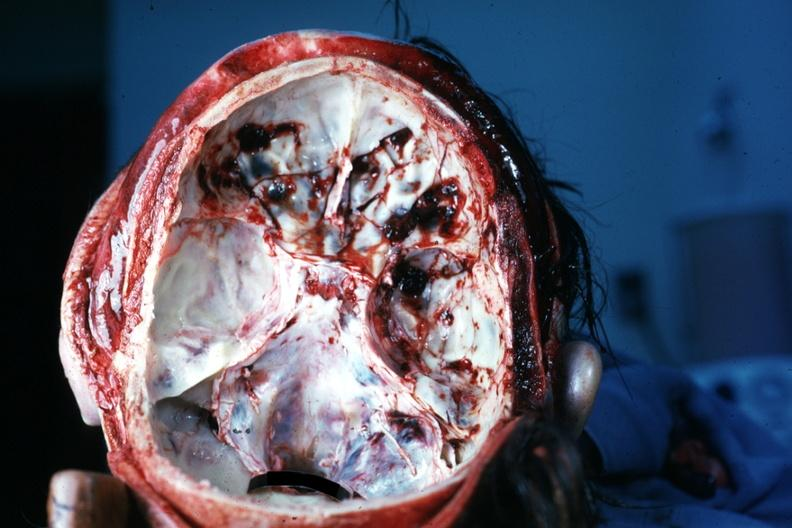what is present?
Answer the question using a single word or phrase. Basilar skull fracture 